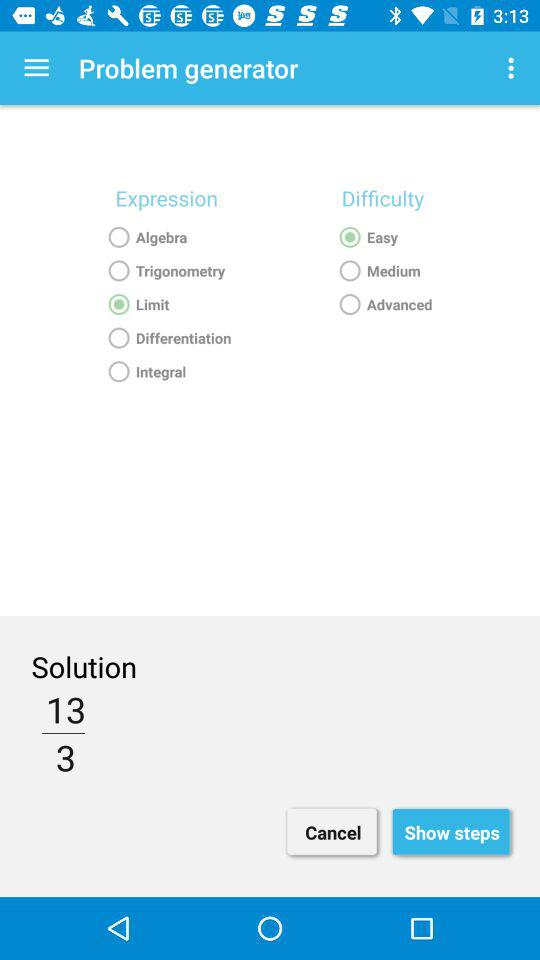How many expression types are there?
Answer the question using a single word or phrase. 5 